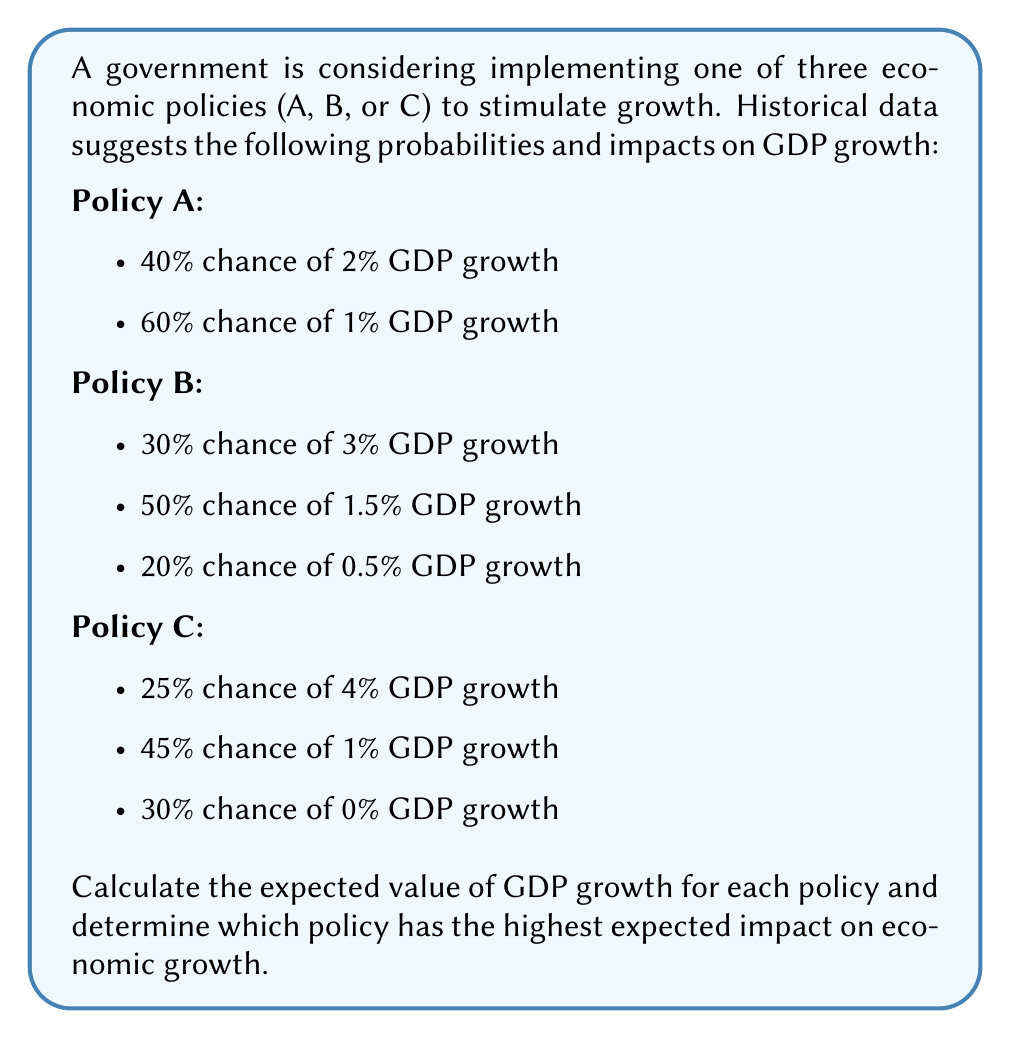What is the answer to this math problem? To solve this problem, we need to calculate the expected value of GDP growth for each policy using the formula for expected value:

$$ E(X) = \sum_{i=1}^n p_i x_i $$

Where $p_i$ is the probability of each outcome and $x_i$ is the value of each outcome.

1. For Policy A:
   $E(A) = (0.40 \times 2\%) + (0.60 \times 1\%)$
   $E(A) = 0.80\% + 0.60\% = 1.40\%$

2. For Policy B:
   $E(B) = (0.30 \times 3\%) + (0.50 \times 1.5\%) + (0.20 \times 0.5\%)$
   $E(B) = 0.90\% + 0.75\% + 0.10\% = 1.75\%$

3. For Policy C:
   $E(C) = (0.25 \times 4\%) + (0.45 \times 1\%) + (0.30 \times 0\%)$
   $E(C) = 1.00\% + 0.45\% + 0\% = 1.45\%$

Comparing the expected values:
Policy A: 1.40%
Policy B: 1.75%
Policy C: 1.45%

Policy B has the highest expected impact on economic growth with an expected GDP growth of 1.75%.
Answer: Policy B, with an expected GDP growth of 1.75% 